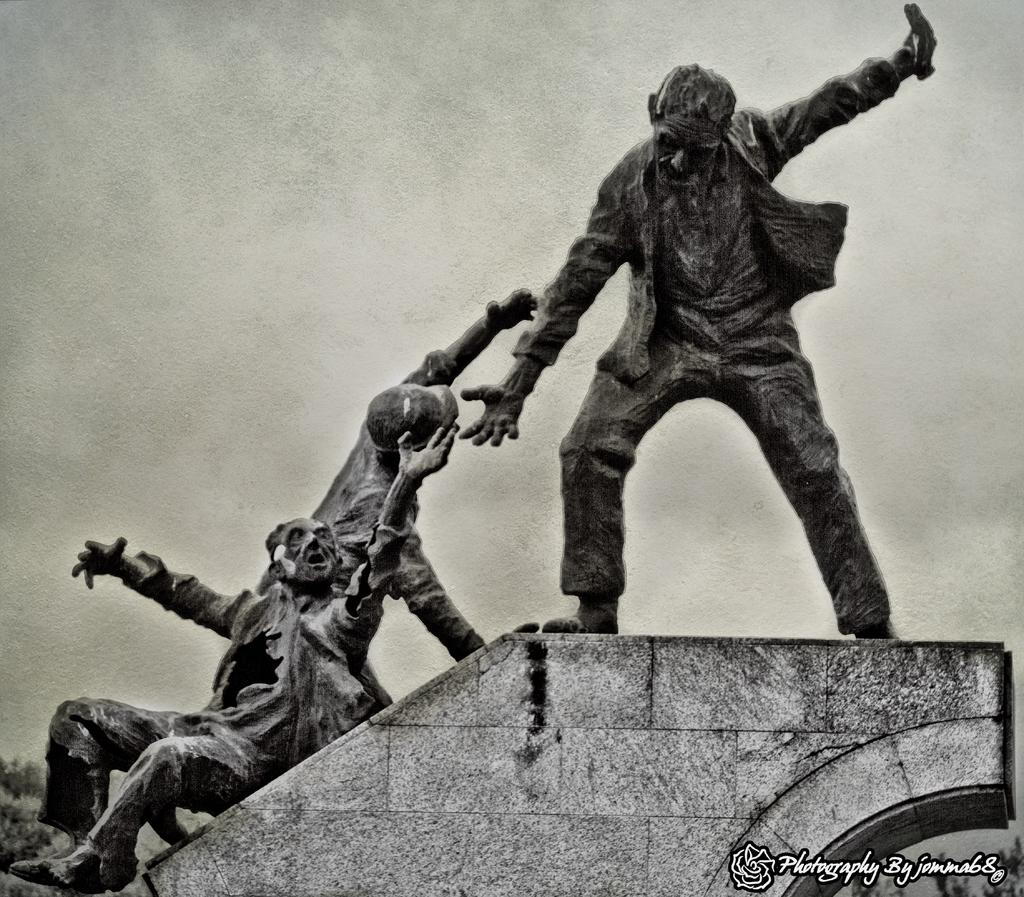What type of objects are depicted in the image? There are human statues in the image. Where are the statues located? The statues are standing on the wall of a building. What is the condition of the sky in the image? The sky is clear in the image. What color scheme is used in the image? The image is in black and white color. How does the statue on the left shake hands with the statue on the right in the image? The statues do not shake hands in the image, as they are stationary and not interacting with each other. 